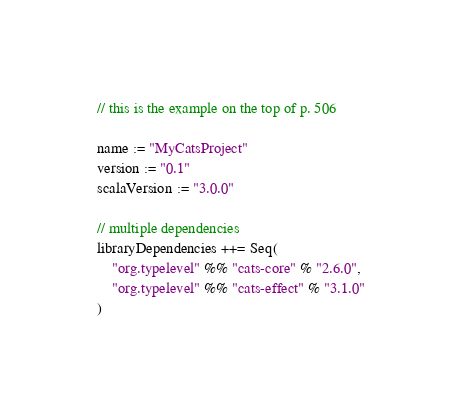<code> <loc_0><loc_0><loc_500><loc_500><_Scala_>// this is the example on the top of p. 506

name := "MyCatsProject"
version := "0.1"
scalaVersion := "3.0.0"

// multiple dependencies
libraryDependencies ++= Seq(
    "org.typelevel" %% "cats-core" % "2.6.0",
    "org.typelevel" %% "cats-effect" % "3.1.0"
)

</code> 